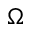Convert formula to latex. <formula><loc_0><loc_0><loc_500><loc_500>\Omega</formula> 